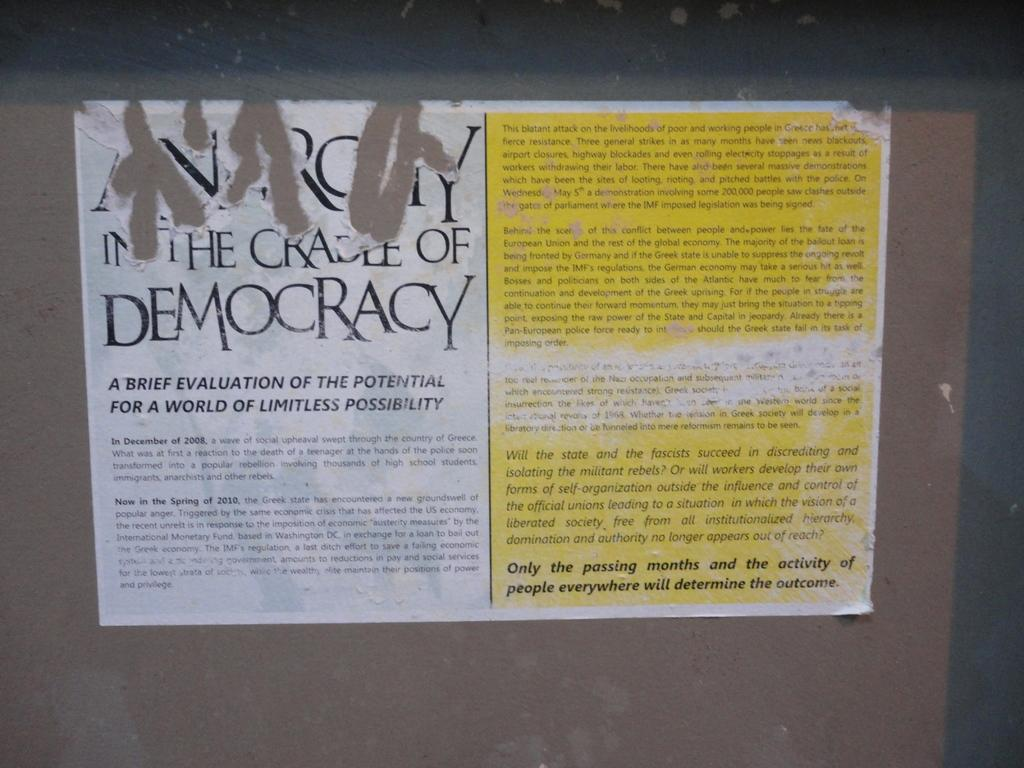What is on the board in the image? There are posts on a board in the image. What can be seen on the posts? There is writing on the posters. How does the pencil interact with the rainstorm in the image? There is no pencil or rainstorm present in the image. 